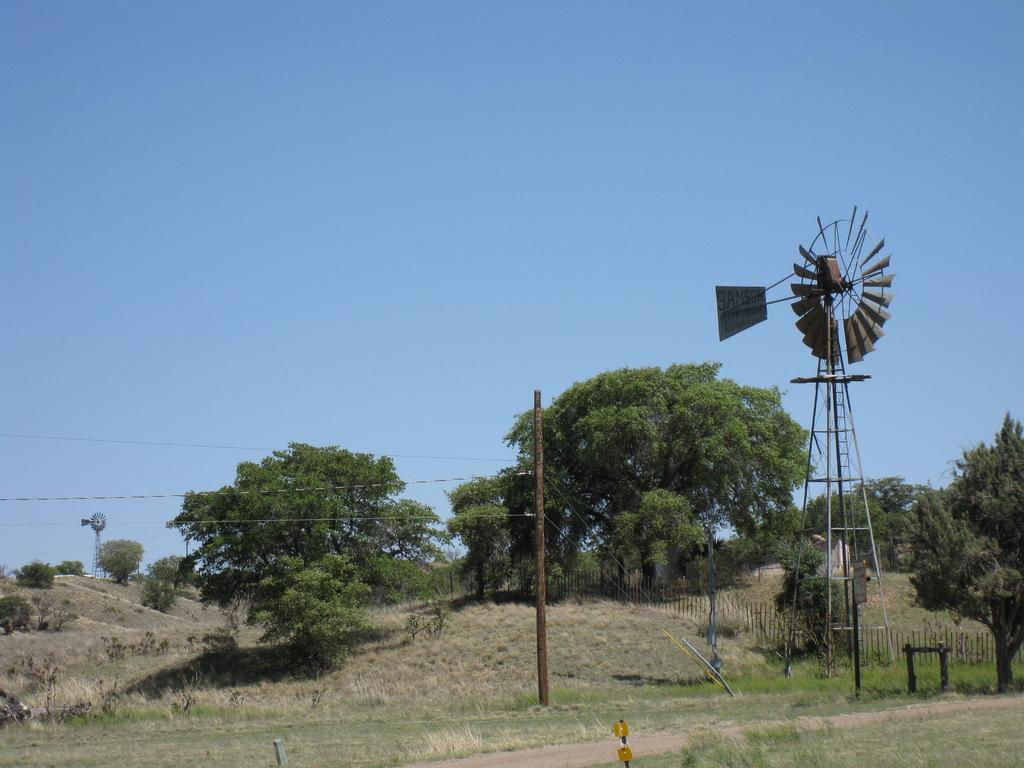What type of vegetation is visible in front of the image? There is grass in front of the image. What other natural elements can be seen in the image? There are trees in the image. What man-made structures are present in the image? There are poles and a windmill in the image. What is the condition of the sky in the background of the image? The sky is visible in the background of the image, and it is clear. Can you see any water in the image? There is no water visible in the image. What is the chin of the windmill doing in the image? The windmill does not have a chin, as it is an inanimate object and not a living being. 